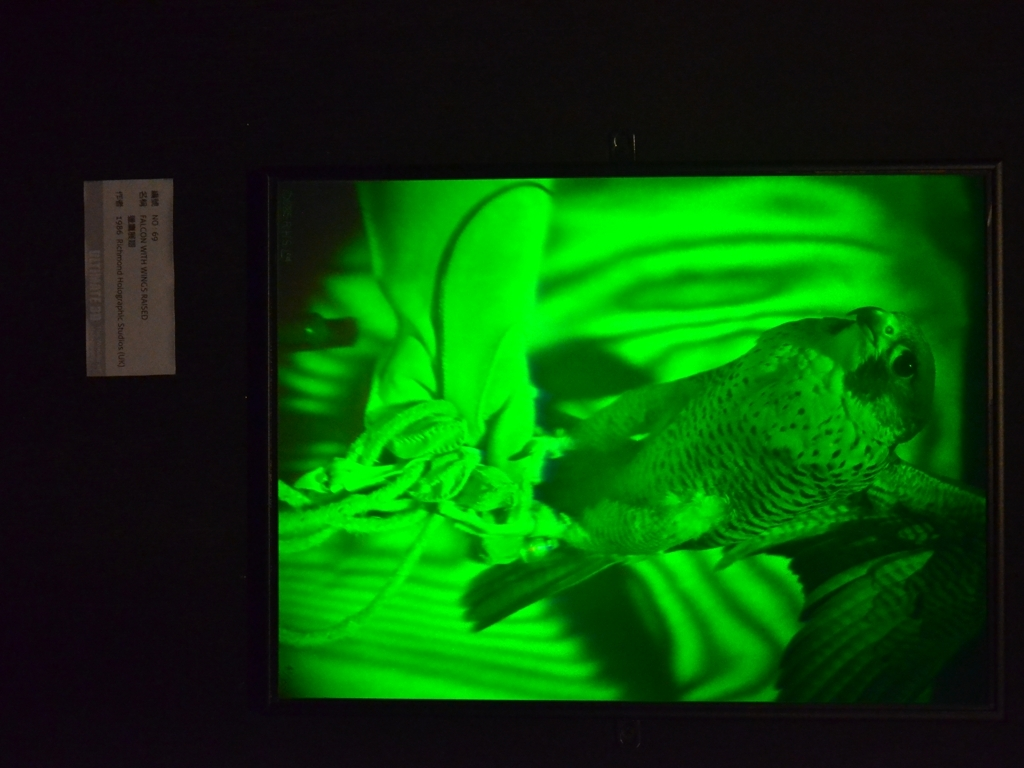Are there any visible artifacts in the image?
A. Yes
B. No
Answer with the option's letter from the given choices directly.
 B. 